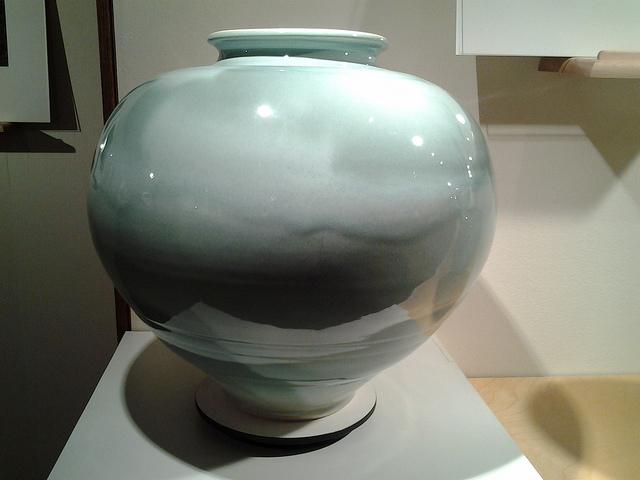What color is this object?
Give a very brief answer. Gray. Are there leaves on the vase?
Quick response, please. No. How many colors are on the vase?
Short answer required. 1. Is the vase transparent?
Keep it brief. No. What sort of object is this?
Answer briefly. Vase. Are there flowers in the vase?
Quick response, please. No. Can the camera man be seen in the reflection of the glass?
Quick response, please. No. 